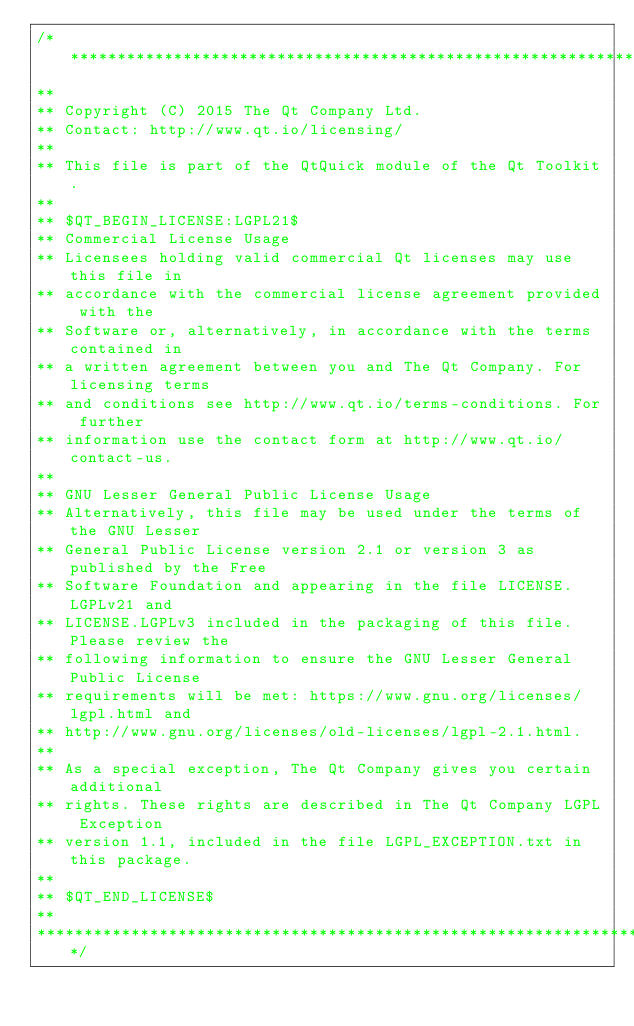<code> <loc_0><loc_0><loc_500><loc_500><_C_>/****************************************************************************
**
** Copyright (C) 2015 The Qt Company Ltd.
** Contact: http://www.qt.io/licensing/
**
** This file is part of the QtQuick module of the Qt Toolkit.
**
** $QT_BEGIN_LICENSE:LGPL21$
** Commercial License Usage
** Licensees holding valid commercial Qt licenses may use this file in
** accordance with the commercial license agreement provided with the
** Software or, alternatively, in accordance with the terms contained in
** a written agreement between you and The Qt Company. For licensing terms
** and conditions see http://www.qt.io/terms-conditions. For further
** information use the contact form at http://www.qt.io/contact-us.
**
** GNU Lesser General Public License Usage
** Alternatively, this file may be used under the terms of the GNU Lesser
** General Public License version 2.1 or version 3 as published by the Free
** Software Foundation and appearing in the file LICENSE.LGPLv21 and
** LICENSE.LGPLv3 included in the packaging of this file. Please review the
** following information to ensure the GNU Lesser General Public License
** requirements will be met: https://www.gnu.org/licenses/lgpl.html and
** http://www.gnu.org/licenses/old-licenses/lgpl-2.1.html.
**
** As a special exception, The Qt Company gives you certain additional
** rights. These rights are described in The Qt Company LGPL Exception
** version 1.1, included in the file LGPL_EXCEPTION.txt in this package.
**
** $QT_END_LICENSE$
**
****************************************************************************/
</code> 